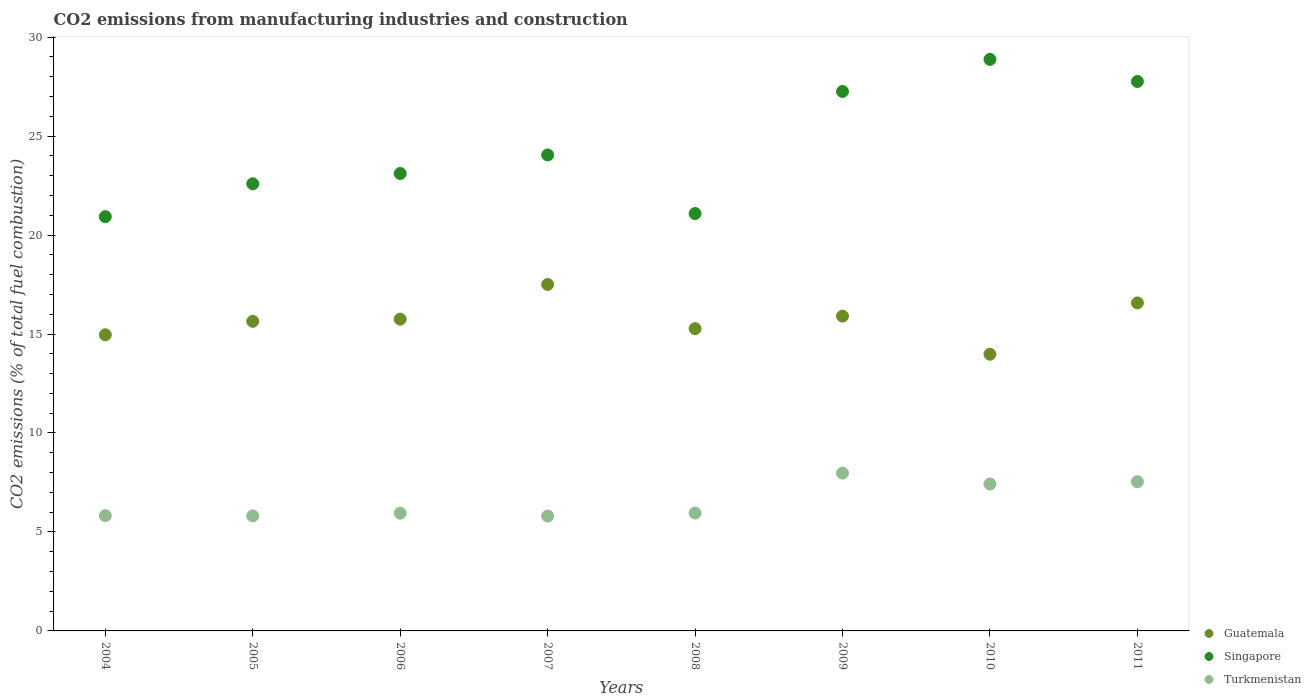How many different coloured dotlines are there?
Offer a terse response. 3. Is the number of dotlines equal to the number of legend labels?
Offer a very short reply. Yes. What is the amount of CO2 emitted in Guatemala in 2005?
Keep it short and to the point. 15.64. Across all years, what is the maximum amount of CO2 emitted in Singapore?
Offer a very short reply. 28.87. Across all years, what is the minimum amount of CO2 emitted in Singapore?
Your answer should be compact. 20.93. In which year was the amount of CO2 emitted in Singapore maximum?
Provide a short and direct response. 2010. What is the total amount of CO2 emitted in Turkmenistan in the graph?
Provide a succinct answer. 52.28. What is the difference between the amount of CO2 emitted in Turkmenistan in 2005 and that in 2007?
Provide a succinct answer. 0.01. What is the difference between the amount of CO2 emitted in Turkmenistan in 2010 and the amount of CO2 emitted in Guatemala in 2009?
Provide a succinct answer. -8.48. What is the average amount of CO2 emitted in Singapore per year?
Your answer should be very brief. 24.45. In the year 2010, what is the difference between the amount of CO2 emitted in Guatemala and amount of CO2 emitted in Turkmenistan?
Provide a short and direct response. 6.56. In how many years, is the amount of CO2 emitted in Guatemala greater than 27 %?
Keep it short and to the point. 0. What is the ratio of the amount of CO2 emitted in Singapore in 2006 to that in 2008?
Your response must be concise. 1.1. Is the amount of CO2 emitted in Guatemala in 2005 less than that in 2007?
Offer a very short reply. Yes. Is the difference between the amount of CO2 emitted in Guatemala in 2005 and 2006 greater than the difference between the amount of CO2 emitted in Turkmenistan in 2005 and 2006?
Offer a terse response. Yes. What is the difference between the highest and the second highest amount of CO2 emitted in Turkmenistan?
Give a very brief answer. 0.43. What is the difference between the highest and the lowest amount of CO2 emitted in Guatemala?
Make the answer very short. 3.52. Is the sum of the amount of CO2 emitted in Guatemala in 2004 and 2008 greater than the maximum amount of CO2 emitted in Turkmenistan across all years?
Give a very brief answer. Yes. Is it the case that in every year, the sum of the amount of CO2 emitted in Guatemala and amount of CO2 emitted in Turkmenistan  is greater than the amount of CO2 emitted in Singapore?
Provide a succinct answer. No. Does the amount of CO2 emitted in Guatemala monotonically increase over the years?
Provide a succinct answer. No. Does the graph contain any zero values?
Provide a succinct answer. No. How many legend labels are there?
Your response must be concise. 3. What is the title of the graph?
Make the answer very short. CO2 emissions from manufacturing industries and construction. Does "Guatemala" appear as one of the legend labels in the graph?
Make the answer very short. Yes. What is the label or title of the Y-axis?
Keep it short and to the point. CO2 emissions (% of total fuel combustion). What is the CO2 emissions (% of total fuel combustion) in Guatemala in 2004?
Your response must be concise. 14.96. What is the CO2 emissions (% of total fuel combustion) of Singapore in 2004?
Offer a very short reply. 20.93. What is the CO2 emissions (% of total fuel combustion) in Turkmenistan in 2004?
Give a very brief answer. 5.82. What is the CO2 emissions (% of total fuel combustion) in Guatemala in 2005?
Make the answer very short. 15.64. What is the CO2 emissions (% of total fuel combustion) in Singapore in 2005?
Offer a terse response. 22.59. What is the CO2 emissions (% of total fuel combustion) of Turkmenistan in 2005?
Keep it short and to the point. 5.81. What is the CO2 emissions (% of total fuel combustion) in Guatemala in 2006?
Provide a short and direct response. 15.75. What is the CO2 emissions (% of total fuel combustion) in Singapore in 2006?
Offer a very short reply. 23.11. What is the CO2 emissions (% of total fuel combustion) in Turkmenistan in 2006?
Provide a succinct answer. 5.95. What is the CO2 emissions (% of total fuel combustion) of Guatemala in 2007?
Make the answer very short. 17.5. What is the CO2 emissions (% of total fuel combustion) of Singapore in 2007?
Your response must be concise. 24.05. What is the CO2 emissions (% of total fuel combustion) in Turkmenistan in 2007?
Your answer should be very brief. 5.8. What is the CO2 emissions (% of total fuel combustion) of Guatemala in 2008?
Offer a very short reply. 15.27. What is the CO2 emissions (% of total fuel combustion) of Singapore in 2008?
Provide a succinct answer. 21.08. What is the CO2 emissions (% of total fuel combustion) in Turkmenistan in 2008?
Your answer should be compact. 5.96. What is the CO2 emissions (% of total fuel combustion) in Guatemala in 2009?
Provide a succinct answer. 15.9. What is the CO2 emissions (% of total fuel combustion) of Singapore in 2009?
Give a very brief answer. 27.25. What is the CO2 emissions (% of total fuel combustion) of Turkmenistan in 2009?
Your answer should be compact. 7.97. What is the CO2 emissions (% of total fuel combustion) of Guatemala in 2010?
Offer a terse response. 13.98. What is the CO2 emissions (% of total fuel combustion) in Singapore in 2010?
Keep it short and to the point. 28.87. What is the CO2 emissions (% of total fuel combustion) of Turkmenistan in 2010?
Make the answer very short. 7.42. What is the CO2 emissions (% of total fuel combustion) of Guatemala in 2011?
Make the answer very short. 16.57. What is the CO2 emissions (% of total fuel combustion) of Singapore in 2011?
Your answer should be very brief. 27.76. What is the CO2 emissions (% of total fuel combustion) in Turkmenistan in 2011?
Offer a very short reply. 7.54. Across all years, what is the maximum CO2 emissions (% of total fuel combustion) of Guatemala?
Your response must be concise. 17.5. Across all years, what is the maximum CO2 emissions (% of total fuel combustion) in Singapore?
Ensure brevity in your answer.  28.87. Across all years, what is the maximum CO2 emissions (% of total fuel combustion) of Turkmenistan?
Your answer should be very brief. 7.97. Across all years, what is the minimum CO2 emissions (% of total fuel combustion) in Guatemala?
Give a very brief answer. 13.98. Across all years, what is the minimum CO2 emissions (% of total fuel combustion) of Singapore?
Offer a terse response. 20.93. Across all years, what is the minimum CO2 emissions (% of total fuel combustion) in Turkmenistan?
Give a very brief answer. 5.8. What is the total CO2 emissions (% of total fuel combustion) of Guatemala in the graph?
Keep it short and to the point. 125.57. What is the total CO2 emissions (% of total fuel combustion) in Singapore in the graph?
Make the answer very short. 195.64. What is the total CO2 emissions (% of total fuel combustion) of Turkmenistan in the graph?
Your response must be concise. 52.28. What is the difference between the CO2 emissions (% of total fuel combustion) in Guatemala in 2004 and that in 2005?
Your response must be concise. -0.68. What is the difference between the CO2 emissions (% of total fuel combustion) in Singapore in 2004 and that in 2005?
Ensure brevity in your answer.  -1.66. What is the difference between the CO2 emissions (% of total fuel combustion) of Turkmenistan in 2004 and that in 2005?
Your answer should be very brief. 0.01. What is the difference between the CO2 emissions (% of total fuel combustion) of Guatemala in 2004 and that in 2006?
Your answer should be compact. -0.79. What is the difference between the CO2 emissions (% of total fuel combustion) in Singapore in 2004 and that in 2006?
Provide a succinct answer. -2.18. What is the difference between the CO2 emissions (% of total fuel combustion) in Turkmenistan in 2004 and that in 2006?
Offer a terse response. -0.12. What is the difference between the CO2 emissions (% of total fuel combustion) of Guatemala in 2004 and that in 2007?
Your answer should be very brief. -2.54. What is the difference between the CO2 emissions (% of total fuel combustion) in Singapore in 2004 and that in 2007?
Give a very brief answer. -3.12. What is the difference between the CO2 emissions (% of total fuel combustion) in Turkmenistan in 2004 and that in 2007?
Offer a very short reply. 0.02. What is the difference between the CO2 emissions (% of total fuel combustion) in Guatemala in 2004 and that in 2008?
Provide a short and direct response. -0.31. What is the difference between the CO2 emissions (% of total fuel combustion) of Singapore in 2004 and that in 2008?
Give a very brief answer. -0.16. What is the difference between the CO2 emissions (% of total fuel combustion) in Turkmenistan in 2004 and that in 2008?
Give a very brief answer. -0.13. What is the difference between the CO2 emissions (% of total fuel combustion) of Guatemala in 2004 and that in 2009?
Your response must be concise. -0.94. What is the difference between the CO2 emissions (% of total fuel combustion) of Singapore in 2004 and that in 2009?
Provide a succinct answer. -6.33. What is the difference between the CO2 emissions (% of total fuel combustion) in Turkmenistan in 2004 and that in 2009?
Your answer should be very brief. -2.15. What is the difference between the CO2 emissions (% of total fuel combustion) of Guatemala in 2004 and that in 2010?
Your response must be concise. 0.98. What is the difference between the CO2 emissions (% of total fuel combustion) of Singapore in 2004 and that in 2010?
Offer a terse response. -7.95. What is the difference between the CO2 emissions (% of total fuel combustion) in Turkmenistan in 2004 and that in 2010?
Offer a very short reply. -1.6. What is the difference between the CO2 emissions (% of total fuel combustion) in Guatemala in 2004 and that in 2011?
Your answer should be very brief. -1.61. What is the difference between the CO2 emissions (% of total fuel combustion) of Singapore in 2004 and that in 2011?
Ensure brevity in your answer.  -6.83. What is the difference between the CO2 emissions (% of total fuel combustion) of Turkmenistan in 2004 and that in 2011?
Give a very brief answer. -1.71. What is the difference between the CO2 emissions (% of total fuel combustion) of Guatemala in 2005 and that in 2006?
Give a very brief answer. -0.11. What is the difference between the CO2 emissions (% of total fuel combustion) in Singapore in 2005 and that in 2006?
Your response must be concise. -0.52. What is the difference between the CO2 emissions (% of total fuel combustion) of Turkmenistan in 2005 and that in 2006?
Offer a very short reply. -0.14. What is the difference between the CO2 emissions (% of total fuel combustion) of Guatemala in 2005 and that in 2007?
Give a very brief answer. -1.86. What is the difference between the CO2 emissions (% of total fuel combustion) in Singapore in 2005 and that in 2007?
Your response must be concise. -1.46. What is the difference between the CO2 emissions (% of total fuel combustion) of Turkmenistan in 2005 and that in 2007?
Offer a very short reply. 0.01. What is the difference between the CO2 emissions (% of total fuel combustion) of Guatemala in 2005 and that in 2008?
Your answer should be compact. 0.37. What is the difference between the CO2 emissions (% of total fuel combustion) of Singapore in 2005 and that in 2008?
Provide a short and direct response. 1.5. What is the difference between the CO2 emissions (% of total fuel combustion) of Turkmenistan in 2005 and that in 2008?
Keep it short and to the point. -0.14. What is the difference between the CO2 emissions (% of total fuel combustion) in Guatemala in 2005 and that in 2009?
Your response must be concise. -0.26. What is the difference between the CO2 emissions (% of total fuel combustion) in Singapore in 2005 and that in 2009?
Your answer should be very brief. -4.66. What is the difference between the CO2 emissions (% of total fuel combustion) in Turkmenistan in 2005 and that in 2009?
Provide a short and direct response. -2.16. What is the difference between the CO2 emissions (% of total fuel combustion) in Guatemala in 2005 and that in 2010?
Give a very brief answer. 1.66. What is the difference between the CO2 emissions (% of total fuel combustion) of Singapore in 2005 and that in 2010?
Offer a terse response. -6.28. What is the difference between the CO2 emissions (% of total fuel combustion) of Turkmenistan in 2005 and that in 2010?
Your answer should be compact. -1.61. What is the difference between the CO2 emissions (% of total fuel combustion) in Guatemala in 2005 and that in 2011?
Your response must be concise. -0.93. What is the difference between the CO2 emissions (% of total fuel combustion) of Singapore in 2005 and that in 2011?
Make the answer very short. -5.17. What is the difference between the CO2 emissions (% of total fuel combustion) of Turkmenistan in 2005 and that in 2011?
Keep it short and to the point. -1.73. What is the difference between the CO2 emissions (% of total fuel combustion) of Guatemala in 2006 and that in 2007?
Your answer should be very brief. -1.75. What is the difference between the CO2 emissions (% of total fuel combustion) in Singapore in 2006 and that in 2007?
Give a very brief answer. -0.94. What is the difference between the CO2 emissions (% of total fuel combustion) in Turkmenistan in 2006 and that in 2007?
Provide a short and direct response. 0.15. What is the difference between the CO2 emissions (% of total fuel combustion) of Guatemala in 2006 and that in 2008?
Give a very brief answer. 0.48. What is the difference between the CO2 emissions (% of total fuel combustion) in Singapore in 2006 and that in 2008?
Give a very brief answer. 2.02. What is the difference between the CO2 emissions (% of total fuel combustion) of Turkmenistan in 2006 and that in 2008?
Offer a very short reply. -0.01. What is the difference between the CO2 emissions (% of total fuel combustion) of Guatemala in 2006 and that in 2009?
Provide a succinct answer. -0.15. What is the difference between the CO2 emissions (% of total fuel combustion) of Singapore in 2006 and that in 2009?
Offer a very short reply. -4.14. What is the difference between the CO2 emissions (% of total fuel combustion) in Turkmenistan in 2006 and that in 2009?
Offer a terse response. -2.02. What is the difference between the CO2 emissions (% of total fuel combustion) of Guatemala in 2006 and that in 2010?
Provide a short and direct response. 1.77. What is the difference between the CO2 emissions (% of total fuel combustion) of Singapore in 2006 and that in 2010?
Give a very brief answer. -5.76. What is the difference between the CO2 emissions (% of total fuel combustion) in Turkmenistan in 2006 and that in 2010?
Your answer should be very brief. -1.47. What is the difference between the CO2 emissions (% of total fuel combustion) of Guatemala in 2006 and that in 2011?
Provide a short and direct response. -0.82. What is the difference between the CO2 emissions (% of total fuel combustion) of Singapore in 2006 and that in 2011?
Your answer should be very brief. -4.65. What is the difference between the CO2 emissions (% of total fuel combustion) in Turkmenistan in 2006 and that in 2011?
Make the answer very short. -1.59. What is the difference between the CO2 emissions (% of total fuel combustion) in Guatemala in 2007 and that in 2008?
Offer a very short reply. 2.23. What is the difference between the CO2 emissions (% of total fuel combustion) in Singapore in 2007 and that in 2008?
Provide a succinct answer. 2.96. What is the difference between the CO2 emissions (% of total fuel combustion) in Turkmenistan in 2007 and that in 2008?
Give a very brief answer. -0.15. What is the difference between the CO2 emissions (% of total fuel combustion) of Guatemala in 2007 and that in 2009?
Your answer should be compact. 1.6. What is the difference between the CO2 emissions (% of total fuel combustion) of Singapore in 2007 and that in 2009?
Your response must be concise. -3.21. What is the difference between the CO2 emissions (% of total fuel combustion) in Turkmenistan in 2007 and that in 2009?
Provide a short and direct response. -2.17. What is the difference between the CO2 emissions (% of total fuel combustion) in Guatemala in 2007 and that in 2010?
Your response must be concise. 3.52. What is the difference between the CO2 emissions (% of total fuel combustion) in Singapore in 2007 and that in 2010?
Your answer should be compact. -4.83. What is the difference between the CO2 emissions (% of total fuel combustion) of Turkmenistan in 2007 and that in 2010?
Give a very brief answer. -1.62. What is the difference between the CO2 emissions (% of total fuel combustion) of Guatemala in 2007 and that in 2011?
Provide a succinct answer. 0.93. What is the difference between the CO2 emissions (% of total fuel combustion) in Singapore in 2007 and that in 2011?
Offer a terse response. -3.71. What is the difference between the CO2 emissions (% of total fuel combustion) of Turkmenistan in 2007 and that in 2011?
Your answer should be compact. -1.74. What is the difference between the CO2 emissions (% of total fuel combustion) of Guatemala in 2008 and that in 2009?
Your answer should be compact. -0.63. What is the difference between the CO2 emissions (% of total fuel combustion) in Singapore in 2008 and that in 2009?
Your response must be concise. -6.17. What is the difference between the CO2 emissions (% of total fuel combustion) in Turkmenistan in 2008 and that in 2009?
Provide a short and direct response. -2.02. What is the difference between the CO2 emissions (% of total fuel combustion) in Guatemala in 2008 and that in 2010?
Keep it short and to the point. 1.29. What is the difference between the CO2 emissions (% of total fuel combustion) in Singapore in 2008 and that in 2010?
Provide a short and direct response. -7.79. What is the difference between the CO2 emissions (% of total fuel combustion) in Turkmenistan in 2008 and that in 2010?
Your answer should be compact. -1.47. What is the difference between the CO2 emissions (% of total fuel combustion) of Guatemala in 2008 and that in 2011?
Offer a very short reply. -1.3. What is the difference between the CO2 emissions (% of total fuel combustion) of Singapore in 2008 and that in 2011?
Your answer should be compact. -6.67. What is the difference between the CO2 emissions (% of total fuel combustion) of Turkmenistan in 2008 and that in 2011?
Make the answer very short. -1.58. What is the difference between the CO2 emissions (% of total fuel combustion) of Guatemala in 2009 and that in 2010?
Your answer should be compact. 1.92. What is the difference between the CO2 emissions (% of total fuel combustion) of Singapore in 2009 and that in 2010?
Provide a succinct answer. -1.62. What is the difference between the CO2 emissions (% of total fuel combustion) in Turkmenistan in 2009 and that in 2010?
Provide a succinct answer. 0.55. What is the difference between the CO2 emissions (% of total fuel combustion) of Guatemala in 2009 and that in 2011?
Keep it short and to the point. -0.67. What is the difference between the CO2 emissions (% of total fuel combustion) in Singapore in 2009 and that in 2011?
Provide a succinct answer. -0.5. What is the difference between the CO2 emissions (% of total fuel combustion) in Turkmenistan in 2009 and that in 2011?
Offer a very short reply. 0.43. What is the difference between the CO2 emissions (% of total fuel combustion) of Guatemala in 2010 and that in 2011?
Ensure brevity in your answer.  -2.59. What is the difference between the CO2 emissions (% of total fuel combustion) in Singapore in 2010 and that in 2011?
Keep it short and to the point. 1.12. What is the difference between the CO2 emissions (% of total fuel combustion) in Turkmenistan in 2010 and that in 2011?
Provide a succinct answer. -0.12. What is the difference between the CO2 emissions (% of total fuel combustion) of Guatemala in 2004 and the CO2 emissions (% of total fuel combustion) of Singapore in 2005?
Keep it short and to the point. -7.63. What is the difference between the CO2 emissions (% of total fuel combustion) of Guatemala in 2004 and the CO2 emissions (% of total fuel combustion) of Turkmenistan in 2005?
Make the answer very short. 9.15. What is the difference between the CO2 emissions (% of total fuel combustion) of Singapore in 2004 and the CO2 emissions (% of total fuel combustion) of Turkmenistan in 2005?
Provide a short and direct response. 15.11. What is the difference between the CO2 emissions (% of total fuel combustion) of Guatemala in 2004 and the CO2 emissions (% of total fuel combustion) of Singapore in 2006?
Offer a terse response. -8.15. What is the difference between the CO2 emissions (% of total fuel combustion) of Guatemala in 2004 and the CO2 emissions (% of total fuel combustion) of Turkmenistan in 2006?
Your response must be concise. 9.01. What is the difference between the CO2 emissions (% of total fuel combustion) of Singapore in 2004 and the CO2 emissions (% of total fuel combustion) of Turkmenistan in 2006?
Your response must be concise. 14.98. What is the difference between the CO2 emissions (% of total fuel combustion) in Guatemala in 2004 and the CO2 emissions (% of total fuel combustion) in Singapore in 2007?
Your answer should be very brief. -9.08. What is the difference between the CO2 emissions (% of total fuel combustion) of Guatemala in 2004 and the CO2 emissions (% of total fuel combustion) of Turkmenistan in 2007?
Give a very brief answer. 9.16. What is the difference between the CO2 emissions (% of total fuel combustion) in Singapore in 2004 and the CO2 emissions (% of total fuel combustion) in Turkmenistan in 2007?
Provide a short and direct response. 15.13. What is the difference between the CO2 emissions (% of total fuel combustion) of Guatemala in 2004 and the CO2 emissions (% of total fuel combustion) of Singapore in 2008?
Your response must be concise. -6.12. What is the difference between the CO2 emissions (% of total fuel combustion) of Guatemala in 2004 and the CO2 emissions (% of total fuel combustion) of Turkmenistan in 2008?
Offer a very short reply. 9. What is the difference between the CO2 emissions (% of total fuel combustion) of Singapore in 2004 and the CO2 emissions (% of total fuel combustion) of Turkmenistan in 2008?
Offer a very short reply. 14.97. What is the difference between the CO2 emissions (% of total fuel combustion) of Guatemala in 2004 and the CO2 emissions (% of total fuel combustion) of Singapore in 2009?
Keep it short and to the point. -12.29. What is the difference between the CO2 emissions (% of total fuel combustion) in Guatemala in 2004 and the CO2 emissions (% of total fuel combustion) in Turkmenistan in 2009?
Provide a succinct answer. 6.99. What is the difference between the CO2 emissions (% of total fuel combustion) of Singapore in 2004 and the CO2 emissions (% of total fuel combustion) of Turkmenistan in 2009?
Offer a terse response. 12.95. What is the difference between the CO2 emissions (% of total fuel combustion) in Guatemala in 2004 and the CO2 emissions (% of total fuel combustion) in Singapore in 2010?
Give a very brief answer. -13.91. What is the difference between the CO2 emissions (% of total fuel combustion) of Guatemala in 2004 and the CO2 emissions (% of total fuel combustion) of Turkmenistan in 2010?
Provide a succinct answer. 7.54. What is the difference between the CO2 emissions (% of total fuel combustion) in Singapore in 2004 and the CO2 emissions (% of total fuel combustion) in Turkmenistan in 2010?
Keep it short and to the point. 13.51. What is the difference between the CO2 emissions (% of total fuel combustion) in Guatemala in 2004 and the CO2 emissions (% of total fuel combustion) in Singapore in 2011?
Your answer should be very brief. -12.8. What is the difference between the CO2 emissions (% of total fuel combustion) in Guatemala in 2004 and the CO2 emissions (% of total fuel combustion) in Turkmenistan in 2011?
Give a very brief answer. 7.42. What is the difference between the CO2 emissions (% of total fuel combustion) in Singapore in 2004 and the CO2 emissions (% of total fuel combustion) in Turkmenistan in 2011?
Offer a terse response. 13.39. What is the difference between the CO2 emissions (% of total fuel combustion) of Guatemala in 2005 and the CO2 emissions (% of total fuel combustion) of Singapore in 2006?
Make the answer very short. -7.47. What is the difference between the CO2 emissions (% of total fuel combustion) in Guatemala in 2005 and the CO2 emissions (% of total fuel combustion) in Turkmenistan in 2006?
Keep it short and to the point. 9.69. What is the difference between the CO2 emissions (% of total fuel combustion) in Singapore in 2005 and the CO2 emissions (% of total fuel combustion) in Turkmenistan in 2006?
Provide a short and direct response. 16.64. What is the difference between the CO2 emissions (% of total fuel combustion) in Guatemala in 2005 and the CO2 emissions (% of total fuel combustion) in Singapore in 2007?
Provide a short and direct response. -8.41. What is the difference between the CO2 emissions (% of total fuel combustion) in Guatemala in 2005 and the CO2 emissions (% of total fuel combustion) in Turkmenistan in 2007?
Provide a short and direct response. 9.84. What is the difference between the CO2 emissions (% of total fuel combustion) of Singapore in 2005 and the CO2 emissions (% of total fuel combustion) of Turkmenistan in 2007?
Offer a very short reply. 16.79. What is the difference between the CO2 emissions (% of total fuel combustion) of Guatemala in 2005 and the CO2 emissions (% of total fuel combustion) of Singapore in 2008?
Your response must be concise. -5.44. What is the difference between the CO2 emissions (% of total fuel combustion) of Guatemala in 2005 and the CO2 emissions (% of total fuel combustion) of Turkmenistan in 2008?
Your answer should be very brief. 9.68. What is the difference between the CO2 emissions (% of total fuel combustion) of Singapore in 2005 and the CO2 emissions (% of total fuel combustion) of Turkmenistan in 2008?
Make the answer very short. 16.63. What is the difference between the CO2 emissions (% of total fuel combustion) in Guatemala in 2005 and the CO2 emissions (% of total fuel combustion) in Singapore in 2009?
Your response must be concise. -11.61. What is the difference between the CO2 emissions (% of total fuel combustion) of Guatemala in 2005 and the CO2 emissions (% of total fuel combustion) of Turkmenistan in 2009?
Ensure brevity in your answer.  7.67. What is the difference between the CO2 emissions (% of total fuel combustion) of Singapore in 2005 and the CO2 emissions (% of total fuel combustion) of Turkmenistan in 2009?
Keep it short and to the point. 14.62. What is the difference between the CO2 emissions (% of total fuel combustion) of Guatemala in 2005 and the CO2 emissions (% of total fuel combustion) of Singapore in 2010?
Offer a terse response. -13.23. What is the difference between the CO2 emissions (% of total fuel combustion) of Guatemala in 2005 and the CO2 emissions (% of total fuel combustion) of Turkmenistan in 2010?
Provide a succinct answer. 8.22. What is the difference between the CO2 emissions (% of total fuel combustion) in Singapore in 2005 and the CO2 emissions (% of total fuel combustion) in Turkmenistan in 2010?
Your answer should be very brief. 15.17. What is the difference between the CO2 emissions (% of total fuel combustion) in Guatemala in 2005 and the CO2 emissions (% of total fuel combustion) in Singapore in 2011?
Your answer should be very brief. -12.12. What is the difference between the CO2 emissions (% of total fuel combustion) in Guatemala in 2005 and the CO2 emissions (% of total fuel combustion) in Turkmenistan in 2011?
Give a very brief answer. 8.1. What is the difference between the CO2 emissions (% of total fuel combustion) of Singapore in 2005 and the CO2 emissions (% of total fuel combustion) of Turkmenistan in 2011?
Your answer should be very brief. 15.05. What is the difference between the CO2 emissions (% of total fuel combustion) in Guatemala in 2006 and the CO2 emissions (% of total fuel combustion) in Singapore in 2007?
Ensure brevity in your answer.  -8.3. What is the difference between the CO2 emissions (% of total fuel combustion) of Guatemala in 2006 and the CO2 emissions (% of total fuel combustion) of Turkmenistan in 2007?
Your response must be concise. 9.95. What is the difference between the CO2 emissions (% of total fuel combustion) of Singapore in 2006 and the CO2 emissions (% of total fuel combustion) of Turkmenistan in 2007?
Offer a terse response. 17.31. What is the difference between the CO2 emissions (% of total fuel combustion) in Guatemala in 2006 and the CO2 emissions (% of total fuel combustion) in Singapore in 2008?
Provide a short and direct response. -5.34. What is the difference between the CO2 emissions (% of total fuel combustion) of Guatemala in 2006 and the CO2 emissions (% of total fuel combustion) of Turkmenistan in 2008?
Ensure brevity in your answer.  9.79. What is the difference between the CO2 emissions (% of total fuel combustion) of Singapore in 2006 and the CO2 emissions (% of total fuel combustion) of Turkmenistan in 2008?
Your answer should be compact. 17.15. What is the difference between the CO2 emissions (% of total fuel combustion) in Guatemala in 2006 and the CO2 emissions (% of total fuel combustion) in Singapore in 2009?
Provide a short and direct response. -11.5. What is the difference between the CO2 emissions (% of total fuel combustion) in Guatemala in 2006 and the CO2 emissions (% of total fuel combustion) in Turkmenistan in 2009?
Ensure brevity in your answer.  7.78. What is the difference between the CO2 emissions (% of total fuel combustion) in Singapore in 2006 and the CO2 emissions (% of total fuel combustion) in Turkmenistan in 2009?
Provide a short and direct response. 15.14. What is the difference between the CO2 emissions (% of total fuel combustion) of Guatemala in 2006 and the CO2 emissions (% of total fuel combustion) of Singapore in 2010?
Provide a succinct answer. -13.12. What is the difference between the CO2 emissions (% of total fuel combustion) in Guatemala in 2006 and the CO2 emissions (% of total fuel combustion) in Turkmenistan in 2010?
Offer a very short reply. 8.33. What is the difference between the CO2 emissions (% of total fuel combustion) of Singapore in 2006 and the CO2 emissions (% of total fuel combustion) of Turkmenistan in 2010?
Your response must be concise. 15.69. What is the difference between the CO2 emissions (% of total fuel combustion) in Guatemala in 2006 and the CO2 emissions (% of total fuel combustion) in Singapore in 2011?
Your response must be concise. -12.01. What is the difference between the CO2 emissions (% of total fuel combustion) of Guatemala in 2006 and the CO2 emissions (% of total fuel combustion) of Turkmenistan in 2011?
Give a very brief answer. 8.21. What is the difference between the CO2 emissions (% of total fuel combustion) in Singapore in 2006 and the CO2 emissions (% of total fuel combustion) in Turkmenistan in 2011?
Your answer should be very brief. 15.57. What is the difference between the CO2 emissions (% of total fuel combustion) in Guatemala in 2007 and the CO2 emissions (% of total fuel combustion) in Singapore in 2008?
Your response must be concise. -3.58. What is the difference between the CO2 emissions (% of total fuel combustion) in Guatemala in 2007 and the CO2 emissions (% of total fuel combustion) in Turkmenistan in 2008?
Provide a short and direct response. 11.55. What is the difference between the CO2 emissions (% of total fuel combustion) in Singapore in 2007 and the CO2 emissions (% of total fuel combustion) in Turkmenistan in 2008?
Your response must be concise. 18.09. What is the difference between the CO2 emissions (% of total fuel combustion) of Guatemala in 2007 and the CO2 emissions (% of total fuel combustion) of Singapore in 2009?
Give a very brief answer. -9.75. What is the difference between the CO2 emissions (% of total fuel combustion) of Guatemala in 2007 and the CO2 emissions (% of total fuel combustion) of Turkmenistan in 2009?
Your response must be concise. 9.53. What is the difference between the CO2 emissions (% of total fuel combustion) of Singapore in 2007 and the CO2 emissions (% of total fuel combustion) of Turkmenistan in 2009?
Make the answer very short. 16.07. What is the difference between the CO2 emissions (% of total fuel combustion) of Guatemala in 2007 and the CO2 emissions (% of total fuel combustion) of Singapore in 2010?
Give a very brief answer. -11.37. What is the difference between the CO2 emissions (% of total fuel combustion) of Guatemala in 2007 and the CO2 emissions (% of total fuel combustion) of Turkmenistan in 2010?
Your answer should be compact. 10.08. What is the difference between the CO2 emissions (% of total fuel combustion) in Singapore in 2007 and the CO2 emissions (% of total fuel combustion) in Turkmenistan in 2010?
Your answer should be compact. 16.62. What is the difference between the CO2 emissions (% of total fuel combustion) in Guatemala in 2007 and the CO2 emissions (% of total fuel combustion) in Singapore in 2011?
Provide a short and direct response. -10.25. What is the difference between the CO2 emissions (% of total fuel combustion) of Guatemala in 2007 and the CO2 emissions (% of total fuel combustion) of Turkmenistan in 2011?
Your answer should be compact. 9.96. What is the difference between the CO2 emissions (% of total fuel combustion) of Singapore in 2007 and the CO2 emissions (% of total fuel combustion) of Turkmenistan in 2011?
Ensure brevity in your answer.  16.51. What is the difference between the CO2 emissions (% of total fuel combustion) of Guatemala in 2008 and the CO2 emissions (% of total fuel combustion) of Singapore in 2009?
Make the answer very short. -11.98. What is the difference between the CO2 emissions (% of total fuel combustion) in Guatemala in 2008 and the CO2 emissions (% of total fuel combustion) in Turkmenistan in 2009?
Your answer should be very brief. 7.3. What is the difference between the CO2 emissions (% of total fuel combustion) in Singapore in 2008 and the CO2 emissions (% of total fuel combustion) in Turkmenistan in 2009?
Your answer should be very brief. 13.11. What is the difference between the CO2 emissions (% of total fuel combustion) in Guatemala in 2008 and the CO2 emissions (% of total fuel combustion) in Singapore in 2010?
Offer a terse response. -13.6. What is the difference between the CO2 emissions (% of total fuel combustion) in Guatemala in 2008 and the CO2 emissions (% of total fuel combustion) in Turkmenistan in 2010?
Offer a very short reply. 7.85. What is the difference between the CO2 emissions (% of total fuel combustion) in Singapore in 2008 and the CO2 emissions (% of total fuel combustion) in Turkmenistan in 2010?
Ensure brevity in your answer.  13.66. What is the difference between the CO2 emissions (% of total fuel combustion) of Guatemala in 2008 and the CO2 emissions (% of total fuel combustion) of Singapore in 2011?
Give a very brief answer. -12.49. What is the difference between the CO2 emissions (% of total fuel combustion) of Guatemala in 2008 and the CO2 emissions (% of total fuel combustion) of Turkmenistan in 2011?
Your response must be concise. 7.73. What is the difference between the CO2 emissions (% of total fuel combustion) of Singapore in 2008 and the CO2 emissions (% of total fuel combustion) of Turkmenistan in 2011?
Your answer should be compact. 13.55. What is the difference between the CO2 emissions (% of total fuel combustion) of Guatemala in 2009 and the CO2 emissions (% of total fuel combustion) of Singapore in 2010?
Offer a very short reply. -12.97. What is the difference between the CO2 emissions (% of total fuel combustion) in Guatemala in 2009 and the CO2 emissions (% of total fuel combustion) in Turkmenistan in 2010?
Ensure brevity in your answer.  8.48. What is the difference between the CO2 emissions (% of total fuel combustion) of Singapore in 2009 and the CO2 emissions (% of total fuel combustion) of Turkmenistan in 2010?
Your answer should be compact. 19.83. What is the difference between the CO2 emissions (% of total fuel combustion) of Guatemala in 2009 and the CO2 emissions (% of total fuel combustion) of Singapore in 2011?
Offer a terse response. -11.85. What is the difference between the CO2 emissions (% of total fuel combustion) of Guatemala in 2009 and the CO2 emissions (% of total fuel combustion) of Turkmenistan in 2011?
Ensure brevity in your answer.  8.36. What is the difference between the CO2 emissions (% of total fuel combustion) of Singapore in 2009 and the CO2 emissions (% of total fuel combustion) of Turkmenistan in 2011?
Your answer should be very brief. 19.71. What is the difference between the CO2 emissions (% of total fuel combustion) of Guatemala in 2010 and the CO2 emissions (% of total fuel combustion) of Singapore in 2011?
Ensure brevity in your answer.  -13.78. What is the difference between the CO2 emissions (% of total fuel combustion) of Guatemala in 2010 and the CO2 emissions (% of total fuel combustion) of Turkmenistan in 2011?
Your answer should be compact. 6.44. What is the difference between the CO2 emissions (% of total fuel combustion) in Singapore in 2010 and the CO2 emissions (% of total fuel combustion) in Turkmenistan in 2011?
Your answer should be compact. 21.33. What is the average CO2 emissions (% of total fuel combustion) of Guatemala per year?
Give a very brief answer. 15.7. What is the average CO2 emissions (% of total fuel combustion) in Singapore per year?
Make the answer very short. 24.45. What is the average CO2 emissions (% of total fuel combustion) of Turkmenistan per year?
Provide a succinct answer. 6.53. In the year 2004, what is the difference between the CO2 emissions (% of total fuel combustion) of Guatemala and CO2 emissions (% of total fuel combustion) of Singapore?
Provide a succinct answer. -5.97. In the year 2004, what is the difference between the CO2 emissions (% of total fuel combustion) in Guatemala and CO2 emissions (% of total fuel combustion) in Turkmenistan?
Provide a short and direct response. 9.14. In the year 2004, what is the difference between the CO2 emissions (% of total fuel combustion) in Singapore and CO2 emissions (% of total fuel combustion) in Turkmenistan?
Make the answer very short. 15.1. In the year 2005, what is the difference between the CO2 emissions (% of total fuel combustion) of Guatemala and CO2 emissions (% of total fuel combustion) of Singapore?
Offer a terse response. -6.95. In the year 2005, what is the difference between the CO2 emissions (% of total fuel combustion) in Guatemala and CO2 emissions (% of total fuel combustion) in Turkmenistan?
Keep it short and to the point. 9.83. In the year 2005, what is the difference between the CO2 emissions (% of total fuel combustion) of Singapore and CO2 emissions (% of total fuel combustion) of Turkmenistan?
Ensure brevity in your answer.  16.78. In the year 2006, what is the difference between the CO2 emissions (% of total fuel combustion) of Guatemala and CO2 emissions (% of total fuel combustion) of Singapore?
Provide a succinct answer. -7.36. In the year 2006, what is the difference between the CO2 emissions (% of total fuel combustion) of Guatemala and CO2 emissions (% of total fuel combustion) of Turkmenistan?
Your response must be concise. 9.8. In the year 2006, what is the difference between the CO2 emissions (% of total fuel combustion) of Singapore and CO2 emissions (% of total fuel combustion) of Turkmenistan?
Provide a succinct answer. 17.16. In the year 2007, what is the difference between the CO2 emissions (% of total fuel combustion) of Guatemala and CO2 emissions (% of total fuel combustion) of Singapore?
Your response must be concise. -6.54. In the year 2007, what is the difference between the CO2 emissions (% of total fuel combustion) in Guatemala and CO2 emissions (% of total fuel combustion) in Turkmenistan?
Make the answer very short. 11.7. In the year 2007, what is the difference between the CO2 emissions (% of total fuel combustion) in Singapore and CO2 emissions (% of total fuel combustion) in Turkmenistan?
Keep it short and to the point. 18.24. In the year 2008, what is the difference between the CO2 emissions (% of total fuel combustion) of Guatemala and CO2 emissions (% of total fuel combustion) of Singapore?
Your answer should be compact. -5.81. In the year 2008, what is the difference between the CO2 emissions (% of total fuel combustion) in Guatemala and CO2 emissions (% of total fuel combustion) in Turkmenistan?
Provide a short and direct response. 9.31. In the year 2008, what is the difference between the CO2 emissions (% of total fuel combustion) of Singapore and CO2 emissions (% of total fuel combustion) of Turkmenistan?
Offer a terse response. 15.13. In the year 2009, what is the difference between the CO2 emissions (% of total fuel combustion) in Guatemala and CO2 emissions (% of total fuel combustion) in Singapore?
Your answer should be compact. -11.35. In the year 2009, what is the difference between the CO2 emissions (% of total fuel combustion) in Guatemala and CO2 emissions (% of total fuel combustion) in Turkmenistan?
Offer a very short reply. 7.93. In the year 2009, what is the difference between the CO2 emissions (% of total fuel combustion) of Singapore and CO2 emissions (% of total fuel combustion) of Turkmenistan?
Your answer should be compact. 19.28. In the year 2010, what is the difference between the CO2 emissions (% of total fuel combustion) of Guatemala and CO2 emissions (% of total fuel combustion) of Singapore?
Provide a short and direct response. -14.89. In the year 2010, what is the difference between the CO2 emissions (% of total fuel combustion) of Guatemala and CO2 emissions (% of total fuel combustion) of Turkmenistan?
Your response must be concise. 6.56. In the year 2010, what is the difference between the CO2 emissions (% of total fuel combustion) in Singapore and CO2 emissions (% of total fuel combustion) in Turkmenistan?
Provide a short and direct response. 21.45. In the year 2011, what is the difference between the CO2 emissions (% of total fuel combustion) in Guatemala and CO2 emissions (% of total fuel combustion) in Singapore?
Ensure brevity in your answer.  -11.19. In the year 2011, what is the difference between the CO2 emissions (% of total fuel combustion) of Guatemala and CO2 emissions (% of total fuel combustion) of Turkmenistan?
Make the answer very short. 9.03. In the year 2011, what is the difference between the CO2 emissions (% of total fuel combustion) of Singapore and CO2 emissions (% of total fuel combustion) of Turkmenistan?
Ensure brevity in your answer.  20.22. What is the ratio of the CO2 emissions (% of total fuel combustion) in Guatemala in 2004 to that in 2005?
Provide a short and direct response. 0.96. What is the ratio of the CO2 emissions (% of total fuel combustion) of Singapore in 2004 to that in 2005?
Your answer should be very brief. 0.93. What is the ratio of the CO2 emissions (% of total fuel combustion) of Turkmenistan in 2004 to that in 2005?
Provide a succinct answer. 1. What is the ratio of the CO2 emissions (% of total fuel combustion) in Guatemala in 2004 to that in 2006?
Offer a very short reply. 0.95. What is the ratio of the CO2 emissions (% of total fuel combustion) of Singapore in 2004 to that in 2006?
Your answer should be very brief. 0.91. What is the ratio of the CO2 emissions (% of total fuel combustion) of Turkmenistan in 2004 to that in 2006?
Your response must be concise. 0.98. What is the ratio of the CO2 emissions (% of total fuel combustion) of Guatemala in 2004 to that in 2007?
Your response must be concise. 0.85. What is the ratio of the CO2 emissions (% of total fuel combustion) of Singapore in 2004 to that in 2007?
Make the answer very short. 0.87. What is the ratio of the CO2 emissions (% of total fuel combustion) of Turkmenistan in 2004 to that in 2007?
Offer a very short reply. 1. What is the ratio of the CO2 emissions (% of total fuel combustion) of Guatemala in 2004 to that in 2008?
Give a very brief answer. 0.98. What is the ratio of the CO2 emissions (% of total fuel combustion) of Singapore in 2004 to that in 2008?
Keep it short and to the point. 0.99. What is the ratio of the CO2 emissions (% of total fuel combustion) in Turkmenistan in 2004 to that in 2008?
Give a very brief answer. 0.98. What is the ratio of the CO2 emissions (% of total fuel combustion) of Guatemala in 2004 to that in 2009?
Your answer should be very brief. 0.94. What is the ratio of the CO2 emissions (% of total fuel combustion) in Singapore in 2004 to that in 2009?
Keep it short and to the point. 0.77. What is the ratio of the CO2 emissions (% of total fuel combustion) in Turkmenistan in 2004 to that in 2009?
Provide a succinct answer. 0.73. What is the ratio of the CO2 emissions (% of total fuel combustion) of Guatemala in 2004 to that in 2010?
Ensure brevity in your answer.  1.07. What is the ratio of the CO2 emissions (% of total fuel combustion) in Singapore in 2004 to that in 2010?
Your answer should be very brief. 0.72. What is the ratio of the CO2 emissions (% of total fuel combustion) of Turkmenistan in 2004 to that in 2010?
Provide a succinct answer. 0.78. What is the ratio of the CO2 emissions (% of total fuel combustion) in Guatemala in 2004 to that in 2011?
Provide a succinct answer. 0.9. What is the ratio of the CO2 emissions (% of total fuel combustion) in Singapore in 2004 to that in 2011?
Your response must be concise. 0.75. What is the ratio of the CO2 emissions (% of total fuel combustion) of Turkmenistan in 2004 to that in 2011?
Your response must be concise. 0.77. What is the ratio of the CO2 emissions (% of total fuel combustion) of Singapore in 2005 to that in 2006?
Your response must be concise. 0.98. What is the ratio of the CO2 emissions (% of total fuel combustion) in Turkmenistan in 2005 to that in 2006?
Keep it short and to the point. 0.98. What is the ratio of the CO2 emissions (% of total fuel combustion) in Guatemala in 2005 to that in 2007?
Ensure brevity in your answer.  0.89. What is the ratio of the CO2 emissions (% of total fuel combustion) in Singapore in 2005 to that in 2007?
Ensure brevity in your answer.  0.94. What is the ratio of the CO2 emissions (% of total fuel combustion) in Turkmenistan in 2005 to that in 2007?
Ensure brevity in your answer.  1. What is the ratio of the CO2 emissions (% of total fuel combustion) of Guatemala in 2005 to that in 2008?
Your response must be concise. 1.02. What is the ratio of the CO2 emissions (% of total fuel combustion) in Singapore in 2005 to that in 2008?
Your response must be concise. 1.07. What is the ratio of the CO2 emissions (% of total fuel combustion) of Guatemala in 2005 to that in 2009?
Give a very brief answer. 0.98. What is the ratio of the CO2 emissions (% of total fuel combustion) of Singapore in 2005 to that in 2009?
Make the answer very short. 0.83. What is the ratio of the CO2 emissions (% of total fuel combustion) of Turkmenistan in 2005 to that in 2009?
Provide a succinct answer. 0.73. What is the ratio of the CO2 emissions (% of total fuel combustion) in Guatemala in 2005 to that in 2010?
Provide a succinct answer. 1.12. What is the ratio of the CO2 emissions (% of total fuel combustion) of Singapore in 2005 to that in 2010?
Ensure brevity in your answer.  0.78. What is the ratio of the CO2 emissions (% of total fuel combustion) in Turkmenistan in 2005 to that in 2010?
Provide a succinct answer. 0.78. What is the ratio of the CO2 emissions (% of total fuel combustion) of Guatemala in 2005 to that in 2011?
Make the answer very short. 0.94. What is the ratio of the CO2 emissions (% of total fuel combustion) of Singapore in 2005 to that in 2011?
Make the answer very short. 0.81. What is the ratio of the CO2 emissions (% of total fuel combustion) of Turkmenistan in 2005 to that in 2011?
Your response must be concise. 0.77. What is the ratio of the CO2 emissions (% of total fuel combustion) in Guatemala in 2006 to that in 2007?
Make the answer very short. 0.9. What is the ratio of the CO2 emissions (% of total fuel combustion) in Singapore in 2006 to that in 2007?
Provide a succinct answer. 0.96. What is the ratio of the CO2 emissions (% of total fuel combustion) of Turkmenistan in 2006 to that in 2007?
Your response must be concise. 1.03. What is the ratio of the CO2 emissions (% of total fuel combustion) of Guatemala in 2006 to that in 2008?
Your response must be concise. 1.03. What is the ratio of the CO2 emissions (% of total fuel combustion) in Singapore in 2006 to that in 2008?
Offer a very short reply. 1.1. What is the ratio of the CO2 emissions (% of total fuel combustion) of Singapore in 2006 to that in 2009?
Provide a succinct answer. 0.85. What is the ratio of the CO2 emissions (% of total fuel combustion) of Turkmenistan in 2006 to that in 2009?
Give a very brief answer. 0.75. What is the ratio of the CO2 emissions (% of total fuel combustion) of Guatemala in 2006 to that in 2010?
Offer a terse response. 1.13. What is the ratio of the CO2 emissions (% of total fuel combustion) in Singapore in 2006 to that in 2010?
Ensure brevity in your answer.  0.8. What is the ratio of the CO2 emissions (% of total fuel combustion) of Turkmenistan in 2006 to that in 2010?
Your response must be concise. 0.8. What is the ratio of the CO2 emissions (% of total fuel combustion) in Guatemala in 2006 to that in 2011?
Offer a terse response. 0.95. What is the ratio of the CO2 emissions (% of total fuel combustion) of Singapore in 2006 to that in 2011?
Provide a succinct answer. 0.83. What is the ratio of the CO2 emissions (% of total fuel combustion) in Turkmenistan in 2006 to that in 2011?
Offer a terse response. 0.79. What is the ratio of the CO2 emissions (% of total fuel combustion) of Guatemala in 2007 to that in 2008?
Give a very brief answer. 1.15. What is the ratio of the CO2 emissions (% of total fuel combustion) of Singapore in 2007 to that in 2008?
Provide a succinct answer. 1.14. What is the ratio of the CO2 emissions (% of total fuel combustion) of Turkmenistan in 2007 to that in 2008?
Your answer should be compact. 0.97. What is the ratio of the CO2 emissions (% of total fuel combustion) of Guatemala in 2007 to that in 2009?
Your response must be concise. 1.1. What is the ratio of the CO2 emissions (% of total fuel combustion) in Singapore in 2007 to that in 2009?
Give a very brief answer. 0.88. What is the ratio of the CO2 emissions (% of total fuel combustion) of Turkmenistan in 2007 to that in 2009?
Your answer should be very brief. 0.73. What is the ratio of the CO2 emissions (% of total fuel combustion) in Guatemala in 2007 to that in 2010?
Keep it short and to the point. 1.25. What is the ratio of the CO2 emissions (% of total fuel combustion) of Singapore in 2007 to that in 2010?
Ensure brevity in your answer.  0.83. What is the ratio of the CO2 emissions (% of total fuel combustion) of Turkmenistan in 2007 to that in 2010?
Ensure brevity in your answer.  0.78. What is the ratio of the CO2 emissions (% of total fuel combustion) in Guatemala in 2007 to that in 2011?
Keep it short and to the point. 1.06. What is the ratio of the CO2 emissions (% of total fuel combustion) of Singapore in 2007 to that in 2011?
Provide a succinct answer. 0.87. What is the ratio of the CO2 emissions (% of total fuel combustion) of Turkmenistan in 2007 to that in 2011?
Give a very brief answer. 0.77. What is the ratio of the CO2 emissions (% of total fuel combustion) of Guatemala in 2008 to that in 2009?
Offer a terse response. 0.96. What is the ratio of the CO2 emissions (% of total fuel combustion) in Singapore in 2008 to that in 2009?
Offer a terse response. 0.77. What is the ratio of the CO2 emissions (% of total fuel combustion) in Turkmenistan in 2008 to that in 2009?
Your response must be concise. 0.75. What is the ratio of the CO2 emissions (% of total fuel combustion) of Guatemala in 2008 to that in 2010?
Give a very brief answer. 1.09. What is the ratio of the CO2 emissions (% of total fuel combustion) in Singapore in 2008 to that in 2010?
Make the answer very short. 0.73. What is the ratio of the CO2 emissions (% of total fuel combustion) of Turkmenistan in 2008 to that in 2010?
Provide a short and direct response. 0.8. What is the ratio of the CO2 emissions (% of total fuel combustion) of Guatemala in 2008 to that in 2011?
Provide a succinct answer. 0.92. What is the ratio of the CO2 emissions (% of total fuel combustion) in Singapore in 2008 to that in 2011?
Offer a terse response. 0.76. What is the ratio of the CO2 emissions (% of total fuel combustion) of Turkmenistan in 2008 to that in 2011?
Keep it short and to the point. 0.79. What is the ratio of the CO2 emissions (% of total fuel combustion) in Guatemala in 2009 to that in 2010?
Provide a succinct answer. 1.14. What is the ratio of the CO2 emissions (% of total fuel combustion) in Singapore in 2009 to that in 2010?
Your answer should be compact. 0.94. What is the ratio of the CO2 emissions (% of total fuel combustion) in Turkmenistan in 2009 to that in 2010?
Your answer should be very brief. 1.07. What is the ratio of the CO2 emissions (% of total fuel combustion) in Guatemala in 2009 to that in 2011?
Provide a succinct answer. 0.96. What is the ratio of the CO2 emissions (% of total fuel combustion) of Singapore in 2009 to that in 2011?
Offer a very short reply. 0.98. What is the ratio of the CO2 emissions (% of total fuel combustion) in Turkmenistan in 2009 to that in 2011?
Your answer should be compact. 1.06. What is the ratio of the CO2 emissions (% of total fuel combustion) of Guatemala in 2010 to that in 2011?
Your answer should be compact. 0.84. What is the ratio of the CO2 emissions (% of total fuel combustion) in Singapore in 2010 to that in 2011?
Give a very brief answer. 1.04. What is the ratio of the CO2 emissions (% of total fuel combustion) in Turkmenistan in 2010 to that in 2011?
Your response must be concise. 0.98. What is the difference between the highest and the second highest CO2 emissions (% of total fuel combustion) of Guatemala?
Provide a short and direct response. 0.93. What is the difference between the highest and the second highest CO2 emissions (% of total fuel combustion) in Singapore?
Keep it short and to the point. 1.12. What is the difference between the highest and the second highest CO2 emissions (% of total fuel combustion) in Turkmenistan?
Your answer should be compact. 0.43. What is the difference between the highest and the lowest CO2 emissions (% of total fuel combustion) in Guatemala?
Provide a succinct answer. 3.52. What is the difference between the highest and the lowest CO2 emissions (% of total fuel combustion) in Singapore?
Make the answer very short. 7.95. What is the difference between the highest and the lowest CO2 emissions (% of total fuel combustion) in Turkmenistan?
Offer a terse response. 2.17. 